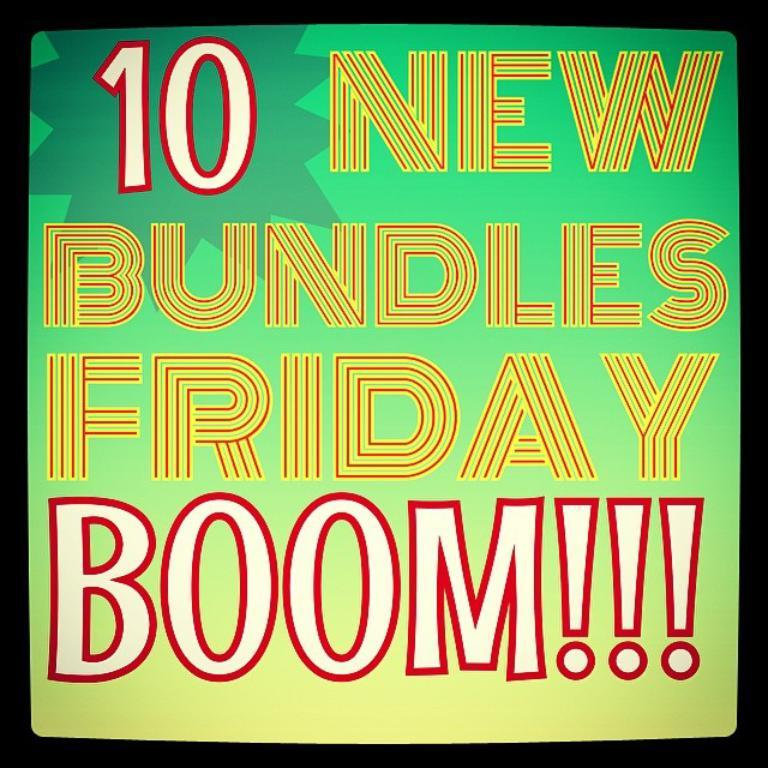<image>
Write a terse but informative summary of the picture. Paper that says "10 New Bundles Friday" in front of a lime green background. 